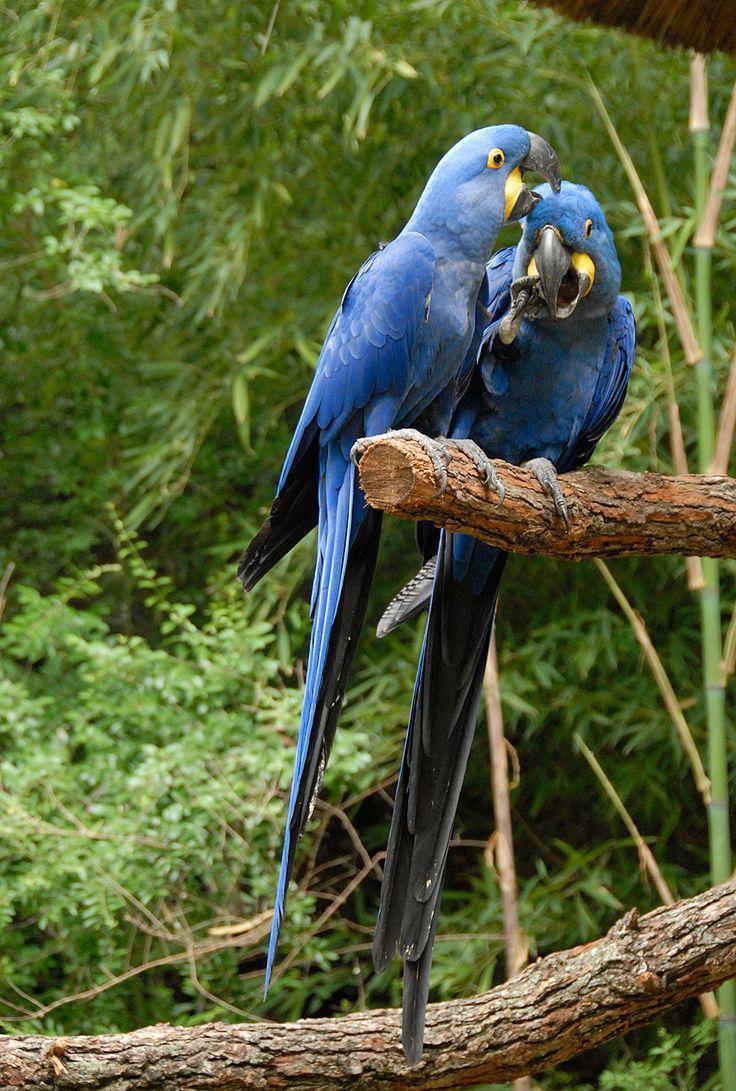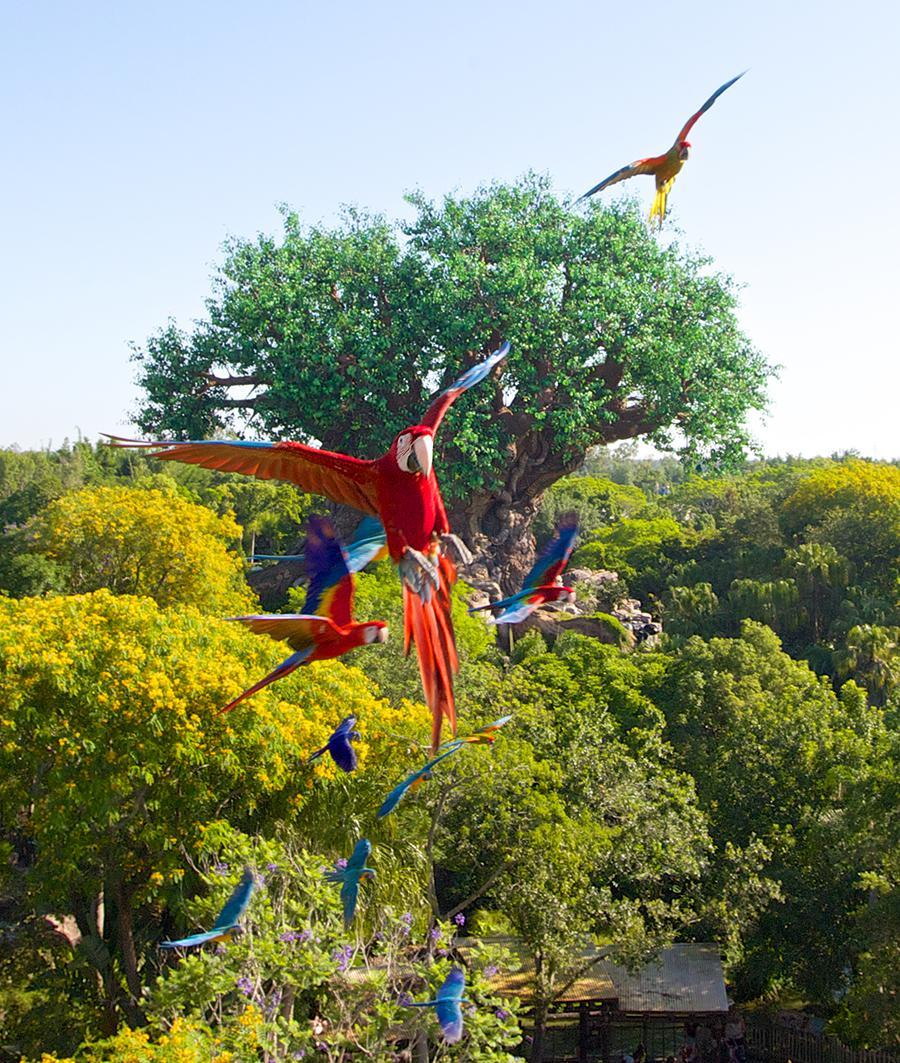The first image is the image on the left, the second image is the image on the right. For the images displayed, is the sentence "An image shows a bird perched on a person's extended hand." factually correct? Answer yes or no. No. The first image is the image on the left, the second image is the image on the right. For the images displayed, is the sentence "Both bird in the image on the left are perched on a branch." factually correct? Answer yes or no. Yes. 